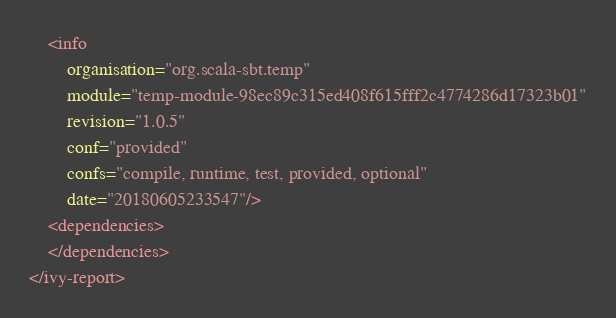<code> <loc_0><loc_0><loc_500><loc_500><_XML_>	<info
		organisation="org.scala-sbt.temp"
		module="temp-module-98ec89c315ed408f615fff2c4774286d17323b01"
		revision="1.0.5"
		conf="provided"
		confs="compile, runtime, test, provided, optional"
		date="20180605233547"/>
	<dependencies>
	</dependencies>
</ivy-report>
</code> 